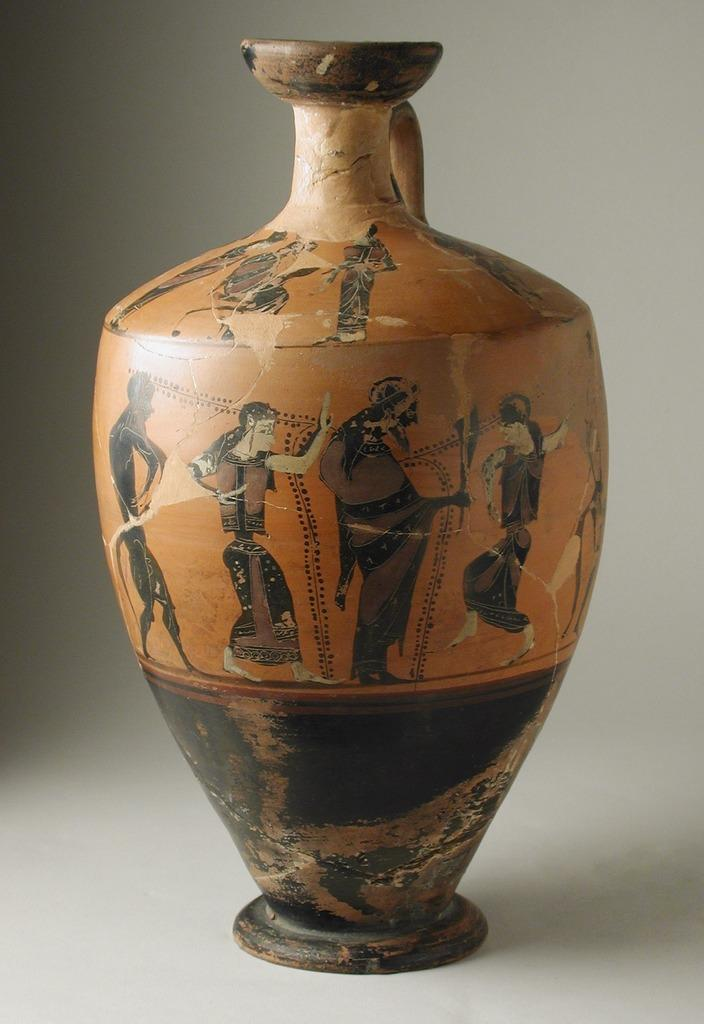What is the main object in the image? There is a pot in the image. What is depicted on the pot? The pot has a depiction of persons. What type of fuel is being used to power the pot in the image? There is no indication in the image that the pot requires fuel or is powered by any means. 